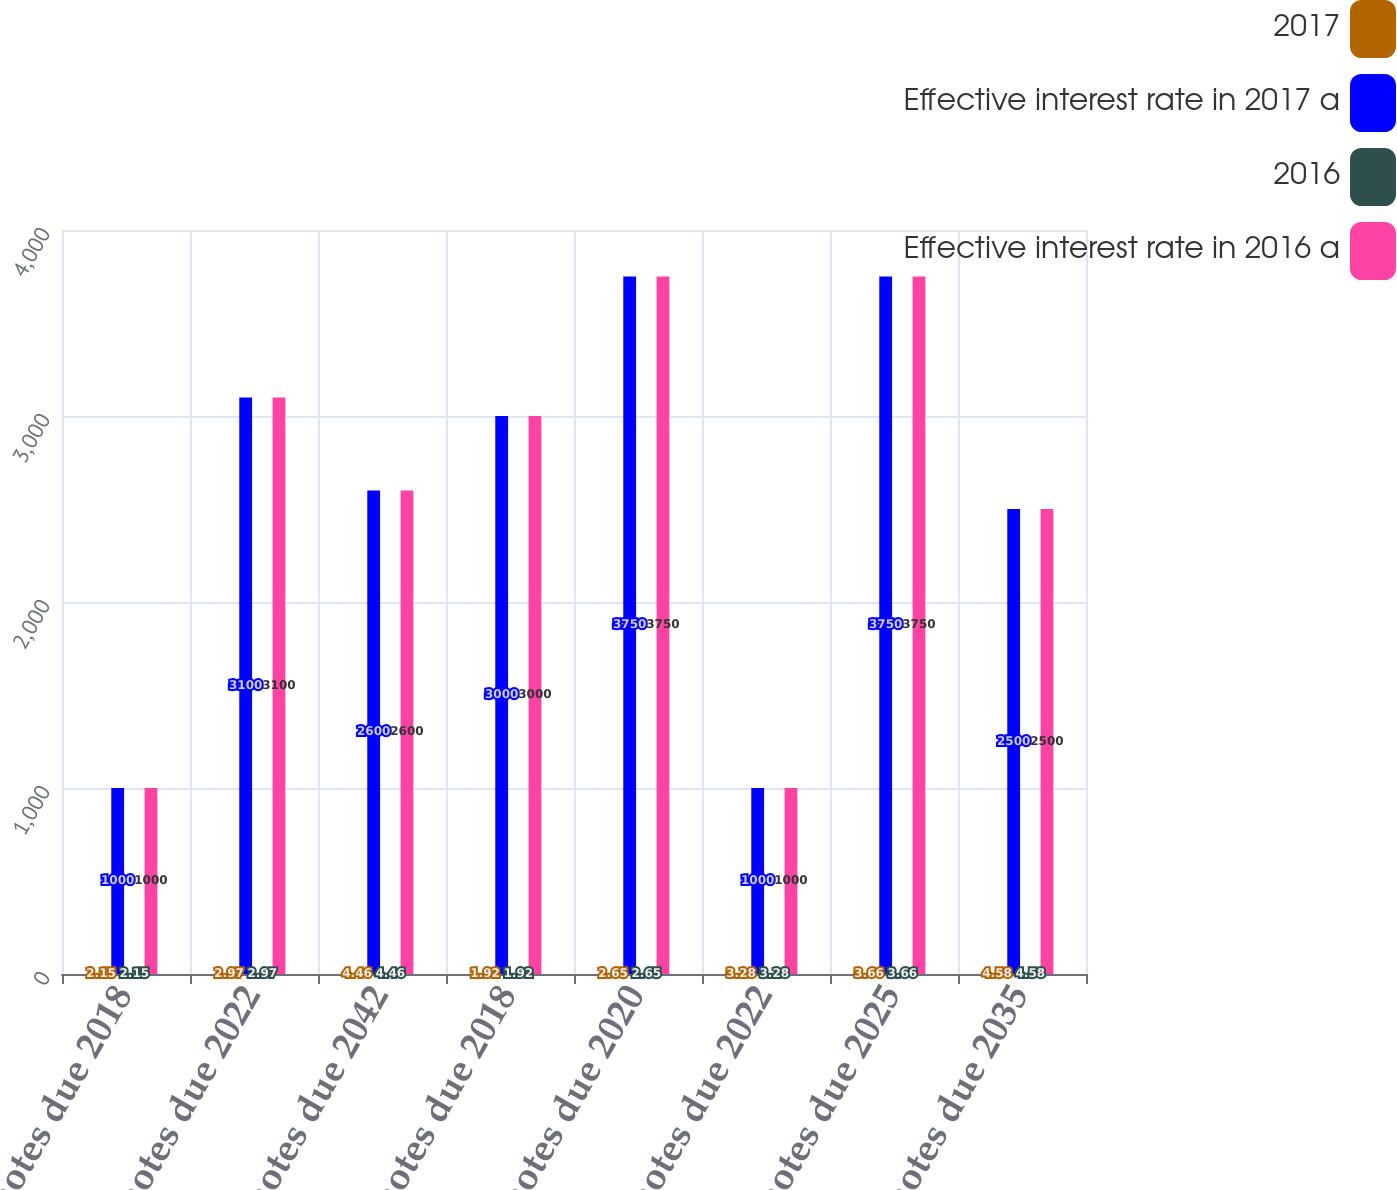Convert chart. <chart><loc_0><loc_0><loc_500><loc_500><stacked_bar_chart><ecel><fcel>200 notes due 2018<fcel>290 notes due 2022<fcel>440 notes due 2042<fcel>180 notes due 2018<fcel>250 notes due 2020<fcel>320 notes due 2022<fcel>360 notes due 2025<fcel>450 notes due 2035<nl><fcel>2017<fcel>2.15<fcel>2.97<fcel>4.46<fcel>1.92<fcel>2.65<fcel>3.28<fcel>3.66<fcel>4.58<nl><fcel>Effective interest rate in 2017 a<fcel>1000<fcel>3100<fcel>2600<fcel>3000<fcel>3750<fcel>1000<fcel>3750<fcel>2500<nl><fcel>2016<fcel>2.15<fcel>2.97<fcel>4.46<fcel>1.92<fcel>2.65<fcel>3.28<fcel>3.66<fcel>4.58<nl><fcel>Effective interest rate in 2016 a<fcel>1000<fcel>3100<fcel>2600<fcel>3000<fcel>3750<fcel>1000<fcel>3750<fcel>2500<nl></chart> 